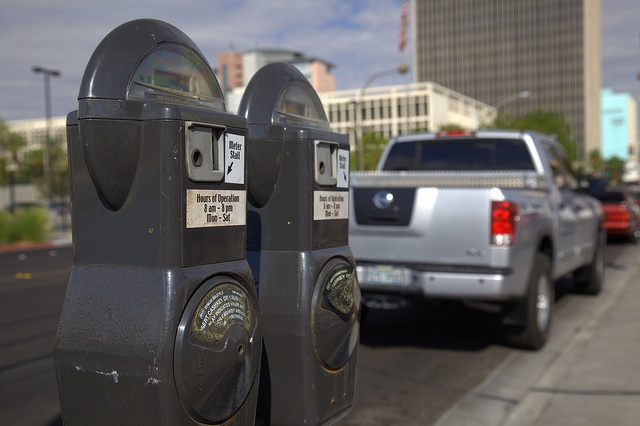Describe the objects in this image and their specific colors. I can see parking meter in gray and black tones, truck in gray, black, darkgray, and lightgray tones, parking meter in gray, black, and darkgray tones, and car in gray, black, brown, and maroon tones in this image. 